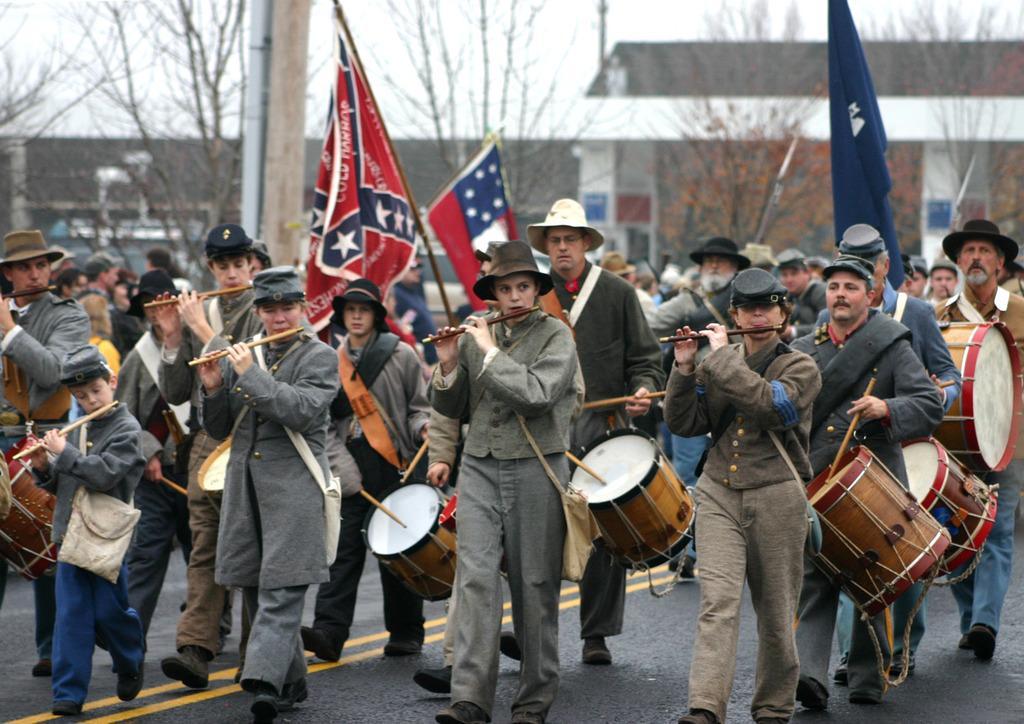How would you summarize this image in a sentence or two? The picture is taken outside the building where people are walking on the roads and playing flutes and drums and there are wearing hats. Three people are holding flags in their hands, where we can see trees and buildings on the roads. 